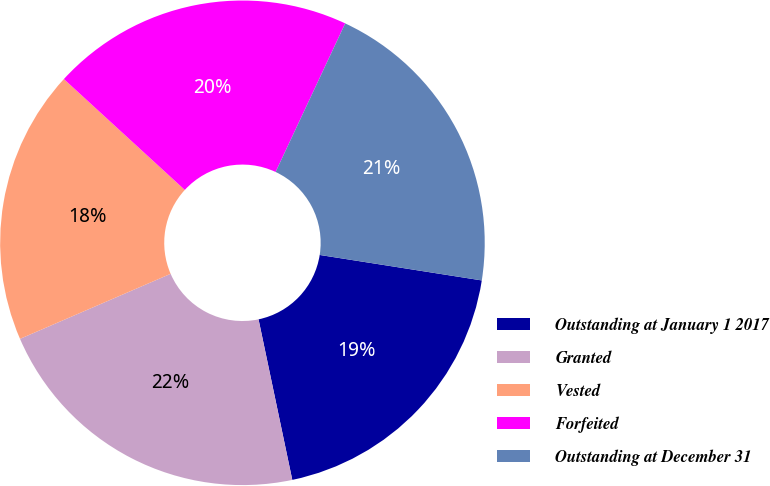Convert chart. <chart><loc_0><loc_0><loc_500><loc_500><pie_chart><fcel>Outstanding at January 1 2017<fcel>Granted<fcel>Vested<fcel>Forfeited<fcel>Outstanding at December 31<nl><fcel>19.22%<fcel>21.81%<fcel>18.3%<fcel>20.16%<fcel>20.51%<nl></chart> 